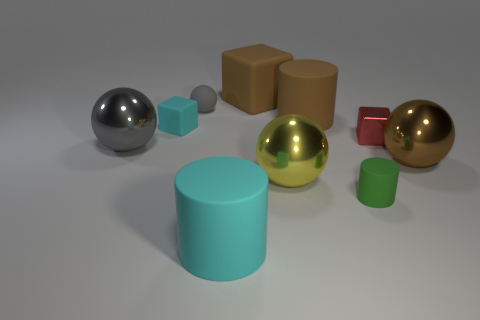There is a big metal thing that is to the left of the brown ball and behind the yellow thing; what is its color?
Your answer should be compact. Gray. What number of things are either gray things that are left of the small gray matte object or green objects?
Your response must be concise. 2. How many other things are there of the same color as the small matte sphere?
Ensure brevity in your answer.  1. Is the number of large yellow objects in front of the small green rubber thing the same as the number of gray spheres?
Your response must be concise. No. How many green objects are left of the metal ball to the left of the big cylinder that is left of the big cube?
Ensure brevity in your answer.  0. There is a red shiny object; is its size the same as the brown metallic object to the right of the large brown matte cube?
Offer a terse response. No. What number of objects are there?
Your response must be concise. 10. There is a metal thing that is behind the big gray metal object; is it the same size as the thing that is on the right side of the tiny red object?
Offer a very short reply. No. There is a small rubber thing that is the same shape as the small metal object; what color is it?
Give a very brief answer. Cyan. Do the gray matte thing and the small green matte object have the same shape?
Offer a very short reply. No. 